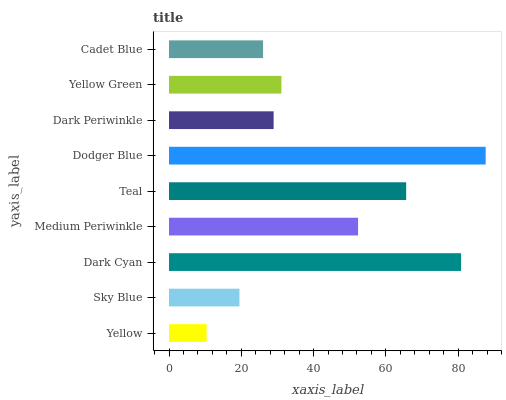Is Yellow the minimum?
Answer yes or no. Yes. Is Dodger Blue the maximum?
Answer yes or no. Yes. Is Sky Blue the minimum?
Answer yes or no. No. Is Sky Blue the maximum?
Answer yes or no. No. Is Sky Blue greater than Yellow?
Answer yes or no. Yes. Is Yellow less than Sky Blue?
Answer yes or no. Yes. Is Yellow greater than Sky Blue?
Answer yes or no. No. Is Sky Blue less than Yellow?
Answer yes or no. No. Is Yellow Green the high median?
Answer yes or no. Yes. Is Yellow Green the low median?
Answer yes or no. Yes. Is Medium Periwinkle the high median?
Answer yes or no. No. Is Dodger Blue the low median?
Answer yes or no. No. 